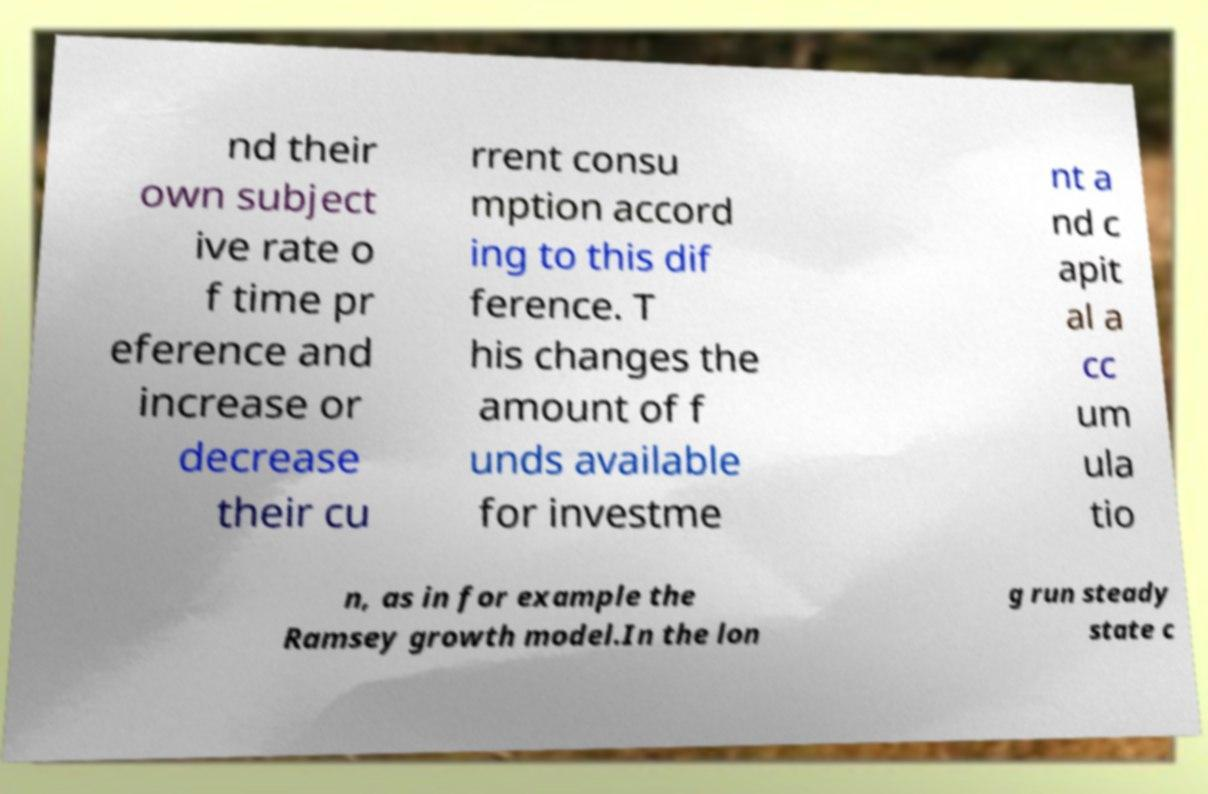Can you accurately transcribe the text from the provided image for me? nd their own subject ive rate o f time pr eference and increase or decrease their cu rrent consu mption accord ing to this dif ference. T his changes the amount of f unds available for investme nt a nd c apit al a cc um ula tio n, as in for example the Ramsey growth model.In the lon g run steady state c 